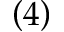<formula> <loc_0><loc_0><loc_500><loc_500>\left ( 4 \right )</formula> 